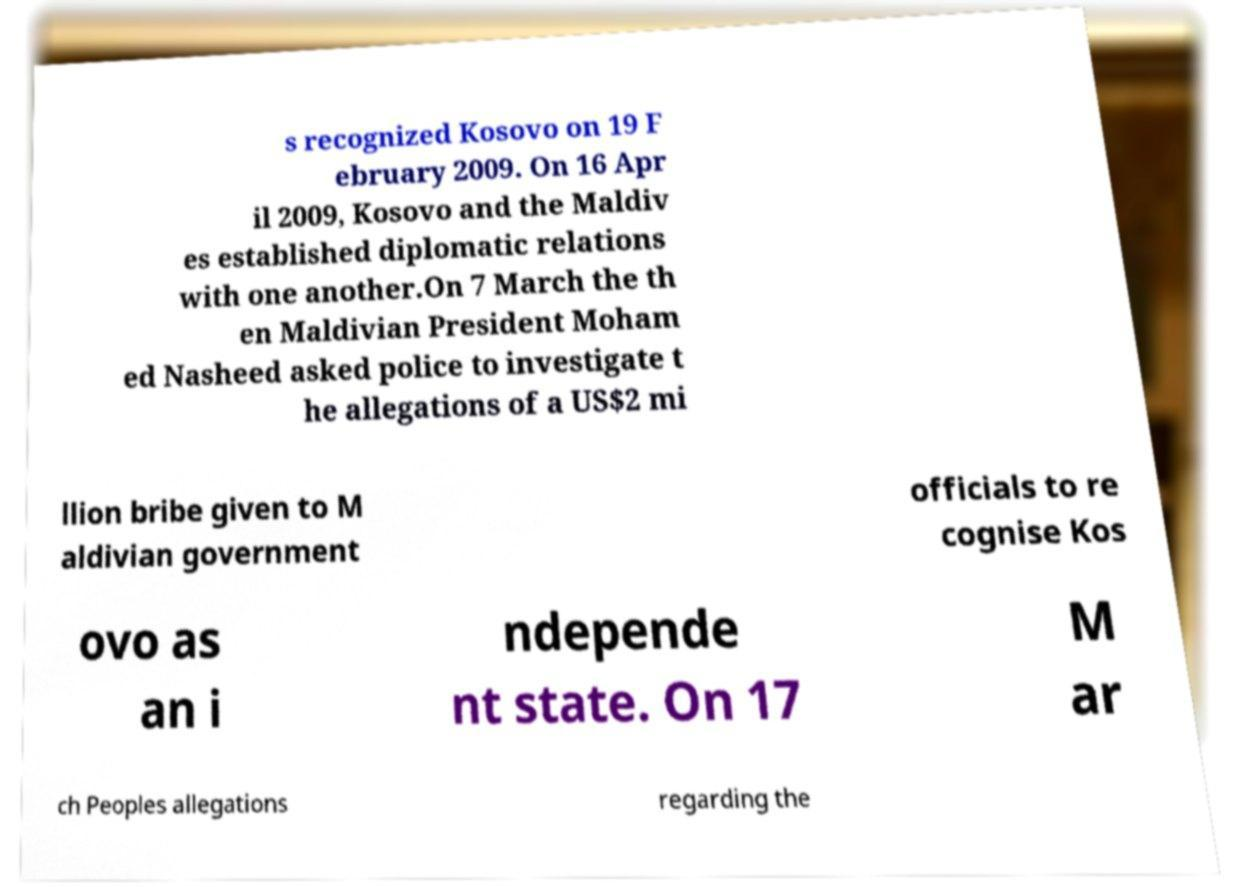For documentation purposes, I need the text within this image transcribed. Could you provide that? s recognized Kosovo on 19 F ebruary 2009. On 16 Apr il 2009, Kosovo and the Maldiv es established diplomatic relations with one another.On 7 March the th en Maldivian President Moham ed Nasheed asked police to investigate t he allegations of a US$2 mi llion bribe given to M aldivian government officials to re cognise Kos ovo as an i ndepende nt state. On 17 M ar ch Peoples allegations regarding the 